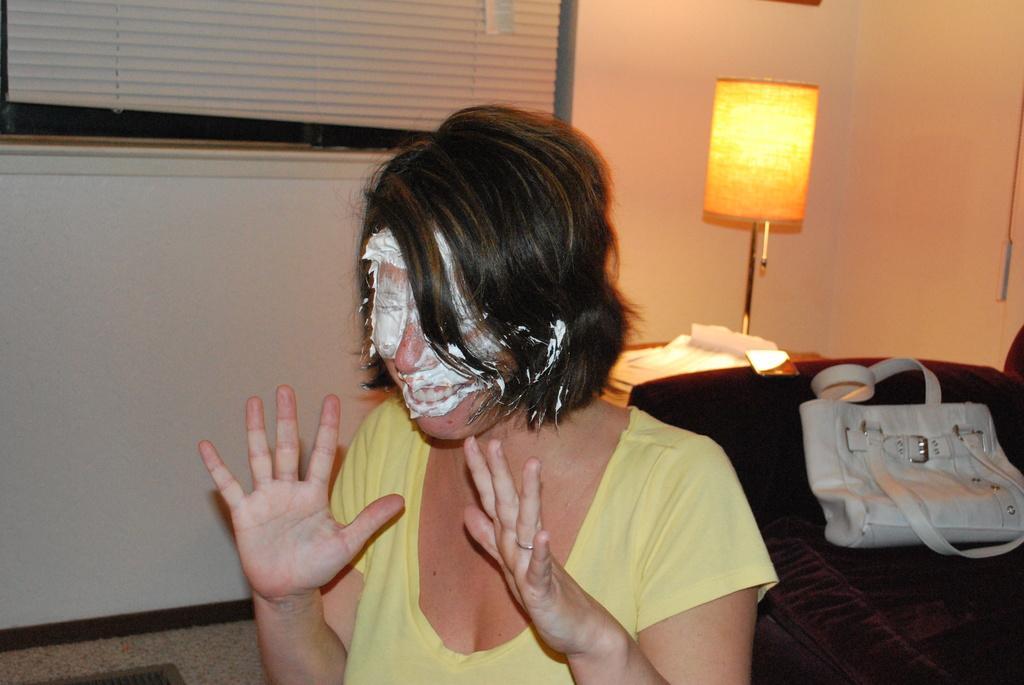How would you summarize this image in a sentence or two? In this picture we can see woman with full of cream on her face and beside to her we can see sofa bag on it and a table on table there is lamp and in background we can see wall with windows, curtain. 